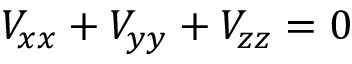<formula> <loc_0><loc_0><loc_500><loc_500>V _ { x x } + V _ { y y } + V _ { z z } = 0</formula> 